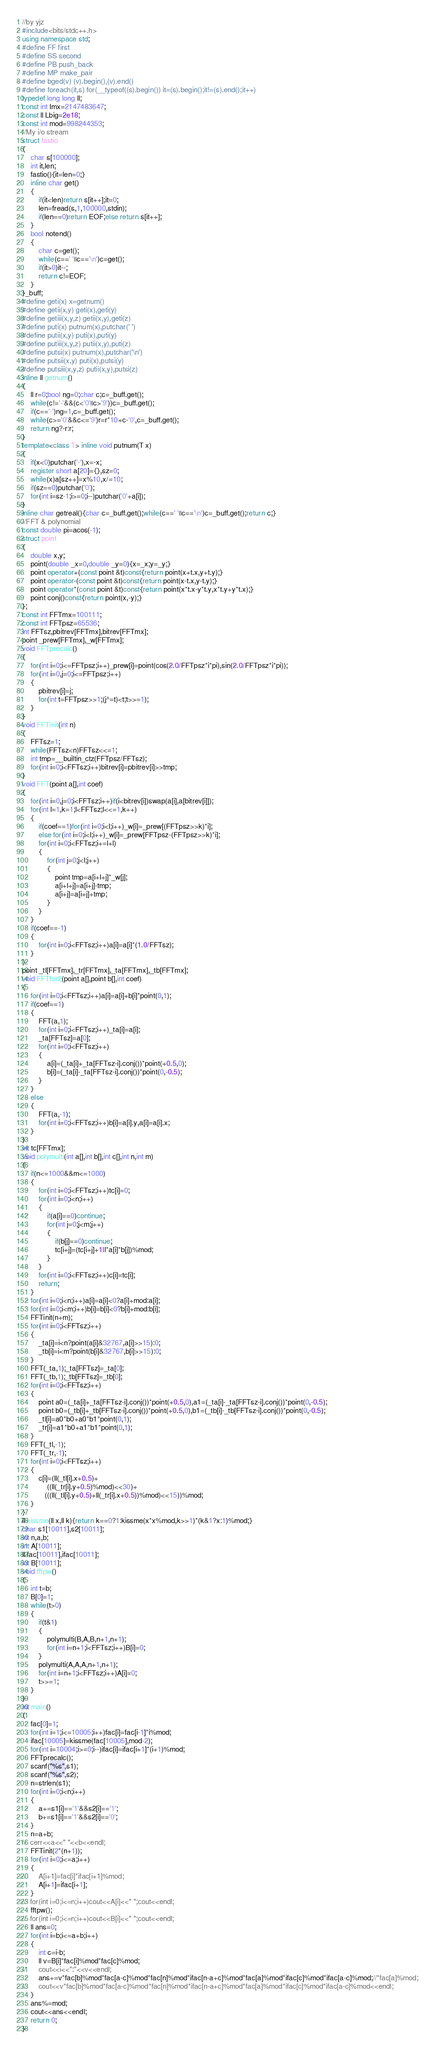Convert code to text. <code><loc_0><loc_0><loc_500><loc_500><_C++_>//by yjz
#include<bits/stdc++.h>
using namespace std;
#define FF first
#define SS second
#define PB push_back
#define MP make_pair
#define bged(v) (v).begin(),(v).end()
#define foreach(it,s) for(__typeof((s).begin()) it=(s).begin();it!=(s).end();it++)
typedef long long ll;
const int Imx=2147483647;
const ll Lbig=2e18;
const int mod=998244353;
//My i/o stream
struct fastio
{
	char s[100000];
	int it,len;
	fastio(){it=len=0;}
	inline char get()
	{
		if(it<len)return s[it++];it=0;
		len=fread(s,1,100000,stdin);
		if(len==0)return EOF;else return s[it++];
	}
	bool notend()
	{
		char c=get();
		while(c==' '||c=='\n')c=get();
		if(it>0)it--;
		return c!=EOF;
	}
}_buff;
#define geti(x) x=getnum()
#define getii(x,y) geti(x),geti(y)
#define getiii(x,y,z) getii(x,y),geti(z)
#define puti(x) putnum(x),putchar(' ')
#define putii(x,y) puti(x),puti(y)
#define putiii(x,y,z) putii(x,y),puti(z)
#define putsi(x) putnum(x),putchar('\n')
#define putsii(x,y) puti(x),putsi(y)
#define putsiii(x,y,z) putii(x,y),putsi(z)
inline ll getnum()
{
	ll r=0;bool ng=0;char c;c=_buff.get();
	while(c!='-'&&(c<'0'||c>'9'))c=_buff.get();
	if(c=='-')ng=1,c=_buff.get();
	while(c>='0'&&c<='9')r=r*10+c-'0',c=_buff.get();
	return ng?-r:r;
}
template<class T> inline void putnum(T x)
{
	if(x<0)putchar('-'),x=-x;
	register short a[20]={},sz=0;
	while(x)a[sz++]=x%10,x/=10;
	if(sz==0)putchar('0');
	for(int i=sz-1;i>=0;i--)putchar('0'+a[i]);
}
inline char getreal(){char c=_buff.get();while(c==' '||c=='\n')c=_buff.get();return c;}
//FFT & polynomial
const double pi=acos(-1);
struct point
{
	double x,y;
	point(double _x=0,double _y=0){x=_x;y=_y;}
	point operator+(const point &t)const{return point(x+t.x,y+t.y);}
	point operator-(const point &t)const{return point(x-t.x,y-t.y);}
	point operator*(const point &t)const{return point(x*t.x-y*t.y,x*t.y+y*t.x);}
	point conj()const{return point(x,-y);}
};
const int FFTmx=100111;
const int FFTpsz=65536;
int FFTsz,pbitrev[FFTmx],bitrev[FFTmx];
point _prew[FFTmx],_w[FFTmx];
void FFTprecalc()
{
	for(int i=0;i<=FFTpsz;i++)_prew[i]=point(cos(2.0/FFTpsz*i*pi),sin(2.0/FFTpsz*i*pi));
	for(int i=0,j=0;i<=FFTpsz;i++)
	{
		pbitrev[i]=j;
		for(int t=FFTpsz>>1;(j^=t)<t;t>>=1);
	}
}
void FFTinit(int n)
{
	FFTsz=1;
	while(FFTsz<n)FFTsz<<=1;
	int tmp=__builtin_ctz(FFTpsz/FFTsz);
	for(int i=0;i<FFTsz;i++)bitrev[i]=pbitrev[i]>>tmp;
}
void FFT(point a[],int coef)
{
	for(int i=0,j=0;i<FFTsz;i++)if(i<bitrev[i])swap(a[i],a[bitrev[i]]);
	for(int l=1,k=1;l<FFTsz;l<<=1,k++)
	{
		if(coef==1)for(int i=0;i<l;i++)_w[i]=_prew[(FFTpsz>>k)*i];
		else for(int i=0;i<l;i++)_w[i]=_prew[FFTpsz-(FFTpsz>>k)*i];
		for(int i=0;i<FFTsz;i+=l+l)
		{
			for(int j=0;j<l;j++)
			{
				point tmp=a[i+l+j]*_w[j];
				a[i+l+j]=a[i+j]-tmp;
				a[i+j]=a[i+j]+tmp;
			}
		}
	}
	if(coef==-1)
	{
		for(int i=0;i<FFTsz;i++)a[i]=a[i]*(1.0/FFTsz);
	}
}
point _tl[FFTmx],_tr[FFTmx],_ta[FFTmx],_tb[FFTmx];
void FFTfor2(point a[],point b[],int coef)
{
	for(int i=0;i<FFTsz;i++)a[i]=a[i]+b[i]*point(0,1);
	if(coef==1)
	{
		FFT(a,1);
		for(int i=0;i<FFTsz;i++)_ta[i]=a[i];
		_ta[FFTsz]=a[0];
		for(int i=0;i<FFTsz;i++)
		{
			a[i]=(_ta[i]+_ta[FFTsz-i].conj())*point(+0.5,0);
			b[i]=(_ta[i]-_ta[FFTsz-i].conj())*point(0,-0.5);
		}
	}
	else 
	{
		FFT(a,-1);
		for(int i=0;i<FFTsz;i++)b[i]=a[i].y,a[i]=a[i].x;
	}
}
int tc[FFTmx];
void polymulti(int a[],int b[],int c[],int n,int m)
{
	if(n<=1000&&m<=1000)
	{
		for(int i=0;i<FFTsz;i++)tc[i]=0;
		for(int i=0;i<n;i++)
		{
			if(a[i]==0)continue;
			for(int j=0;j<m;j++)
			{
				if(b[j]==0)continue;
				tc[i+j]=(tc[i+j]+1ll*a[i]*b[j])%mod;
			}
		}
		for(int i=0;i<FFTsz;i++)c[i]=tc[i];
		return;
	}
	for(int i=0;i<n;i++)a[i]=a[i]<0?a[i]+mod:a[i];
	for(int i=0;i<m;i++)b[i]=b[i]<0?b[i]+mod:b[i];
	FFTinit(n+m);
	for(int i=0;i<FFTsz;i++)
	{
		_ta[i]=i<n?point(a[i]&32767,a[i]>>15):0;
		_tb[i]=i<m?point(b[i]&32767,b[i]>>15):0;
	}
	FFT(_ta,1);_ta[FFTsz]=_ta[0];
	FFT(_tb,1);_tb[FFTsz]=_tb[0];
	for(int i=0;i<FFTsz;i++)
	{
		point a0=(_ta[i]+_ta[FFTsz-i].conj())*point(+0.5,0),a1=(_ta[i]-_ta[FFTsz-i].conj())*point(0,-0.5);
		point b0=(_tb[i]+_tb[FFTsz-i].conj())*point(+0.5,0),b1=(_tb[i]-_tb[FFTsz-i].conj())*point(0,-0.5);
		_tl[i]=a0*b0+a0*b1*point(0,1);
		_tr[i]=a1*b0+a1*b1*point(0,1);
	}
	FFT(_tl,-1);
	FFT(_tr,-1);
	for(int i=0;i<FFTsz;i++)
	{
		c[i]=(ll(_tl[i].x+0.5)+
		    ((ll(_tr[i].y+0.5)%mod)<<30)+
	       (((ll(_tl[i].y+0.5)+ll(_tr[i].x+0.5))%mod)<<15))%mod;
	}
}
ll kissme(ll x,ll k){return k==0?1:kissme(x*x%mod,k>>1)*(k&1?x:1)%mod;}
char s1[10011],s2[10011];
int n,a,b;
int A[10011];
ll fac[10011],ifac[10011];
int B[10011];
void fftpw()
{
	int t=b;
	B[0]=1;
	while(t>0)
	{
		if(t&1)
		{
			polymulti(B,A,B,n+1,n+1);
			for(int i=n+1;i<FFTsz;i++)B[i]=0;
		}
		polymulti(A,A,A,n+1,n+1);
		for(int i=n+1;i<FFTsz;i++)A[i]=0;
		t>>=1;
	}
}
int main()
{
	fac[0]=1;
	for(int i=1;i<=10005;i++)fac[i]=fac[i-1]*i%mod;
	ifac[10005]=kissme(fac[10005],mod-2);
	for(int i=10004;i>=0;i--)ifac[i]=ifac[i+1]*(i+1)%mod;
	FFTprecalc();
	scanf("%s",s1);
	scanf("%s",s2);
	n=strlen(s1);
	for(int i=0;i<n;i++)
	{
		a+=s1[i]=='1'&&s2[i]=='1';
		b+=s1[i]=='1'&&s2[i]=='0';
	}
	n=a+b;
//	cerr<<a<<" "<<b<<endl;
	FFTinit(2*(n+1));
	for(int i=0;i<=a;i++)
	{
//		A[i+1]=fac[i]*ifac[i+1]%mod;
		A[i+1]=ifac[i+1];
	}
//	for(int i=0;i<=n;i++)cout<<A[i]<<" ";cout<<endl;
	fftpw();
//	for(int i=0;i<=n;i++)cout<<B[i]<<" ";cout<<endl;
	ll ans=0;
	for(int i=b;i<=a+b;i++)
	{
		int c=i-b;
		ll v=B[i]*fac[i]%mod*fac[c]%mod;
//		cout<<i<<":"<<v<<endl;
		ans+=v*fac[b]%mod*fac[a-c]%mod*fac[n]%mod*ifac[n-a+c]%mod*fac[a]%mod*ifac[c]%mod*ifac[a-c]%mod;//*fac[a]%mod;
//		cout<<v*fac[b]%mod*fac[a-c]%mod*fac[n]%mod*ifac[n-a+c]%mod*fac[a]%mod*ifac[c]%mod*ifac[a-c]%mod<<endl;
	}
	ans%=mod;
	cout<<ans<<endl;
	return 0;
}</code> 